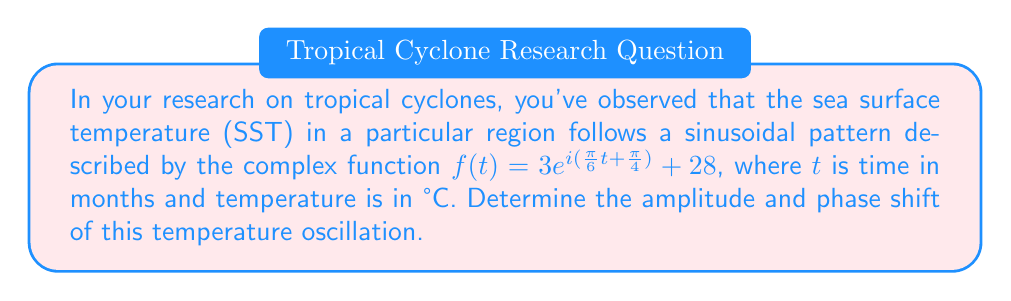Show me your answer to this math problem. To find the amplitude and phase shift, we need to analyze the complex function:

1) The general form of a complex sinusoidal function is:
   $f(t) = Ae^{i(\omega t + \phi)} + C$

   Where:
   $A$ is the amplitude
   $\omega$ is the angular frequency
   $\phi$ is the phase shift
   $C$ is the vertical shift

2) Comparing our function to the general form:
   $f(t) = 3e^{i(\frac{\pi}{6}t + \frac{\pi}{4})} + 28$

   We can identify:
   $A = 3$ (amplitude)
   $\omega = \frac{\pi}{6}$ (angular frequency)
   $\phi = \frac{\pi}{4}$ (phase shift)
   $C = 28$ (vertical shift)

3) The amplitude is directly given as 3°C.

4) The phase shift is $\frac{\pi}{4}$ radians. To convert this to months (since $t$ is in months), we use:

   $\text{Phase shift in months} = \frac{\phi}{\omega} = \frac{\frac{\pi}{4}}{\frac{\pi}{6}} = \frac{3}{2} = 1.5$ months

Therefore, the amplitude is 3°C and the phase shift is 1.5 months.
Answer: Amplitude: 3°C, Phase shift: 1.5 months 